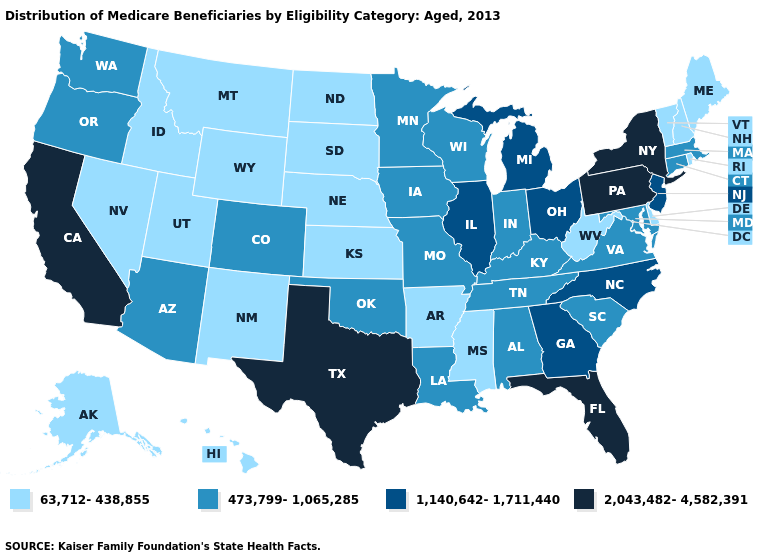Name the states that have a value in the range 2,043,482-4,582,391?
Be succinct. California, Florida, New York, Pennsylvania, Texas. Name the states that have a value in the range 2,043,482-4,582,391?
Write a very short answer. California, Florida, New York, Pennsylvania, Texas. Among the states that border Utah , which have the highest value?
Give a very brief answer. Arizona, Colorado. Name the states that have a value in the range 473,799-1,065,285?
Concise answer only. Alabama, Arizona, Colorado, Connecticut, Indiana, Iowa, Kentucky, Louisiana, Maryland, Massachusetts, Minnesota, Missouri, Oklahoma, Oregon, South Carolina, Tennessee, Virginia, Washington, Wisconsin. Name the states that have a value in the range 2,043,482-4,582,391?
Give a very brief answer. California, Florida, New York, Pennsylvania, Texas. What is the lowest value in the Northeast?
Be succinct. 63,712-438,855. Name the states that have a value in the range 2,043,482-4,582,391?
Be succinct. California, Florida, New York, Pennsylvania, Texas. Does the first symbol in the legend represent the smallest category?
Be succinct. Yes. Name the states that have a value in the range 2,043,482-4,582,391?
Short answer required. California, Florida, New York, Pennsylvania, Texas. Name the states that have a value in the range 63,712-438,855?
Give a very brief answer. Alaska, Arkansas, Delaware, Hawaii, Idaho, Kansas, Maine, Mississippi, Montana, Nebraska, Nevada, New Hampshire, New Mexico, North Dakota, Rhode Island, South Dakota, Utah, Vermont, West Virginia, Wyoming. What is the value of Alabama?
Quick response, please. 473,799-1,065,285. What is the lowest value in the USA?
Concise answer only. 63,712-438,855. What is the highest value in the USA?
Be succinct. 2,043,482-4,582,391. Which states have the lowest value in the USA?
Be succinct. Alaska, Arkansas, Delaware, Hawaii, Idaho, Kansas, Maine, Mississippi, Montana, Nebraska, Nevada, New Hampshire, New Mexico, North Dakota, Rhode Island, South Dakota, Utah, Vermont, West Virginia, Wyoming. Does the map have missing data?
Write a very short answer. No. 